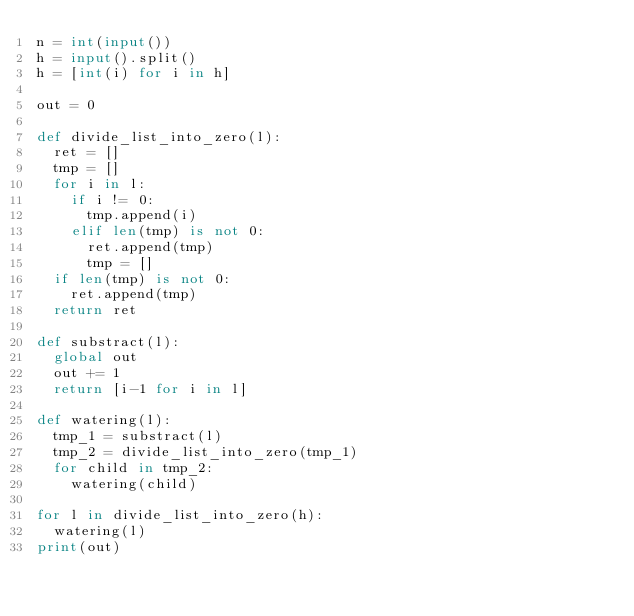Convert code to text. <code><loc_0><loc_0><loc_500><loc_500><_Python_>n = int(input())
h = input().split()
h = [int(i) for i in h]

out = 0

def divide_list_into_zero(l):
  ret = []
  tmp = []
  for i in l:
    if i != 0:
      tmp.append(i)
    elif len(tmp) is not 0:
      ret.append(tmp)
      tmp = []
  if len(tmp) is not 0:
    ret.append(tmp)
  return ret

def substract(l):
  global out
  out += 1
  return [i-1 for i in l]

def watering(l):
  tmp_1 = substract(l)
  tmp_2 = divide_list_into_zero(tmp_1)
  for child in tmp_2:
    watering(child)

for l in divide_list_into_zero(h):
  watering(l)
print(out)</code> 